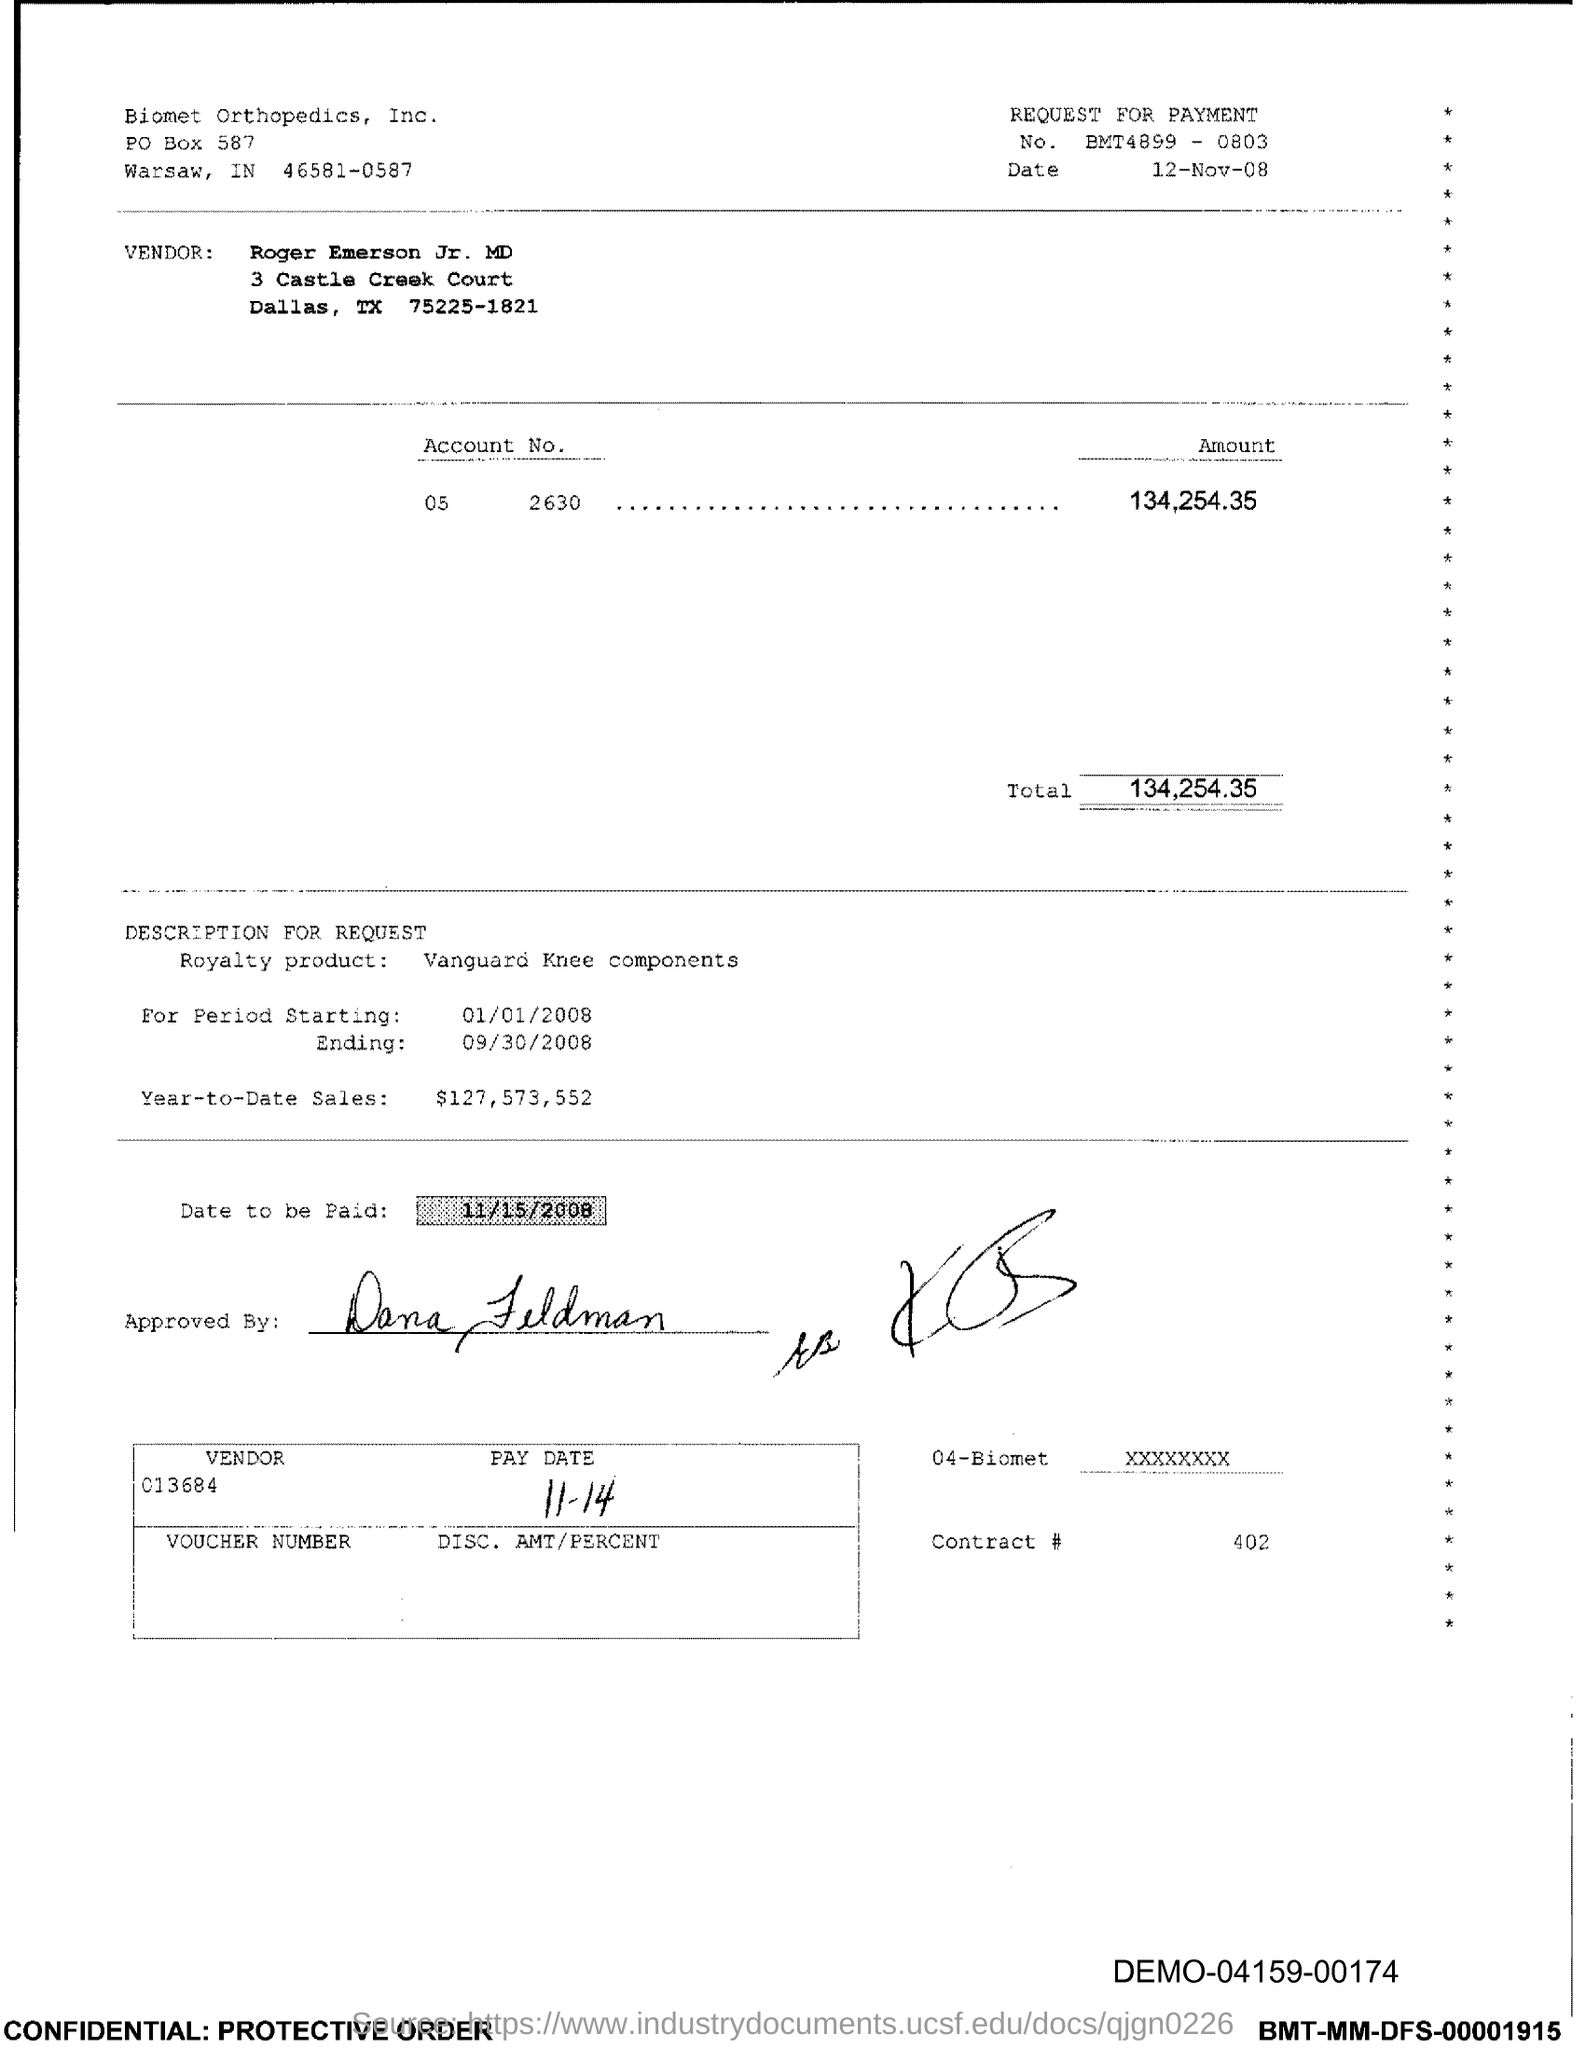Identify some key points in this picture. The royalty product mentioned in the document is Vanguard Knee components. What is the contract number, specifically 402, referenced in the document? It is evident from the document that biomet orthopedics is mentioned in the header of the document. According to the document, the total amount to be paid is 134,254,356. The issued date of this document is 12-Nov-08. 